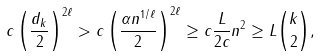<formula> <loc_0><loc_0><loc_500><loc_500>c \left ( \frac { d _ { k } } { 2 } \right ) ^ { 2 \ell } > c \left ( \frac { \alpha n ^ { 1 / \ell } } { 2 } \right ) ^ { 2 \ell } \geq c \frac { L } { 2 c } n ^ { 2 } \geq L \binom { k } { 2 } ,</formula> 